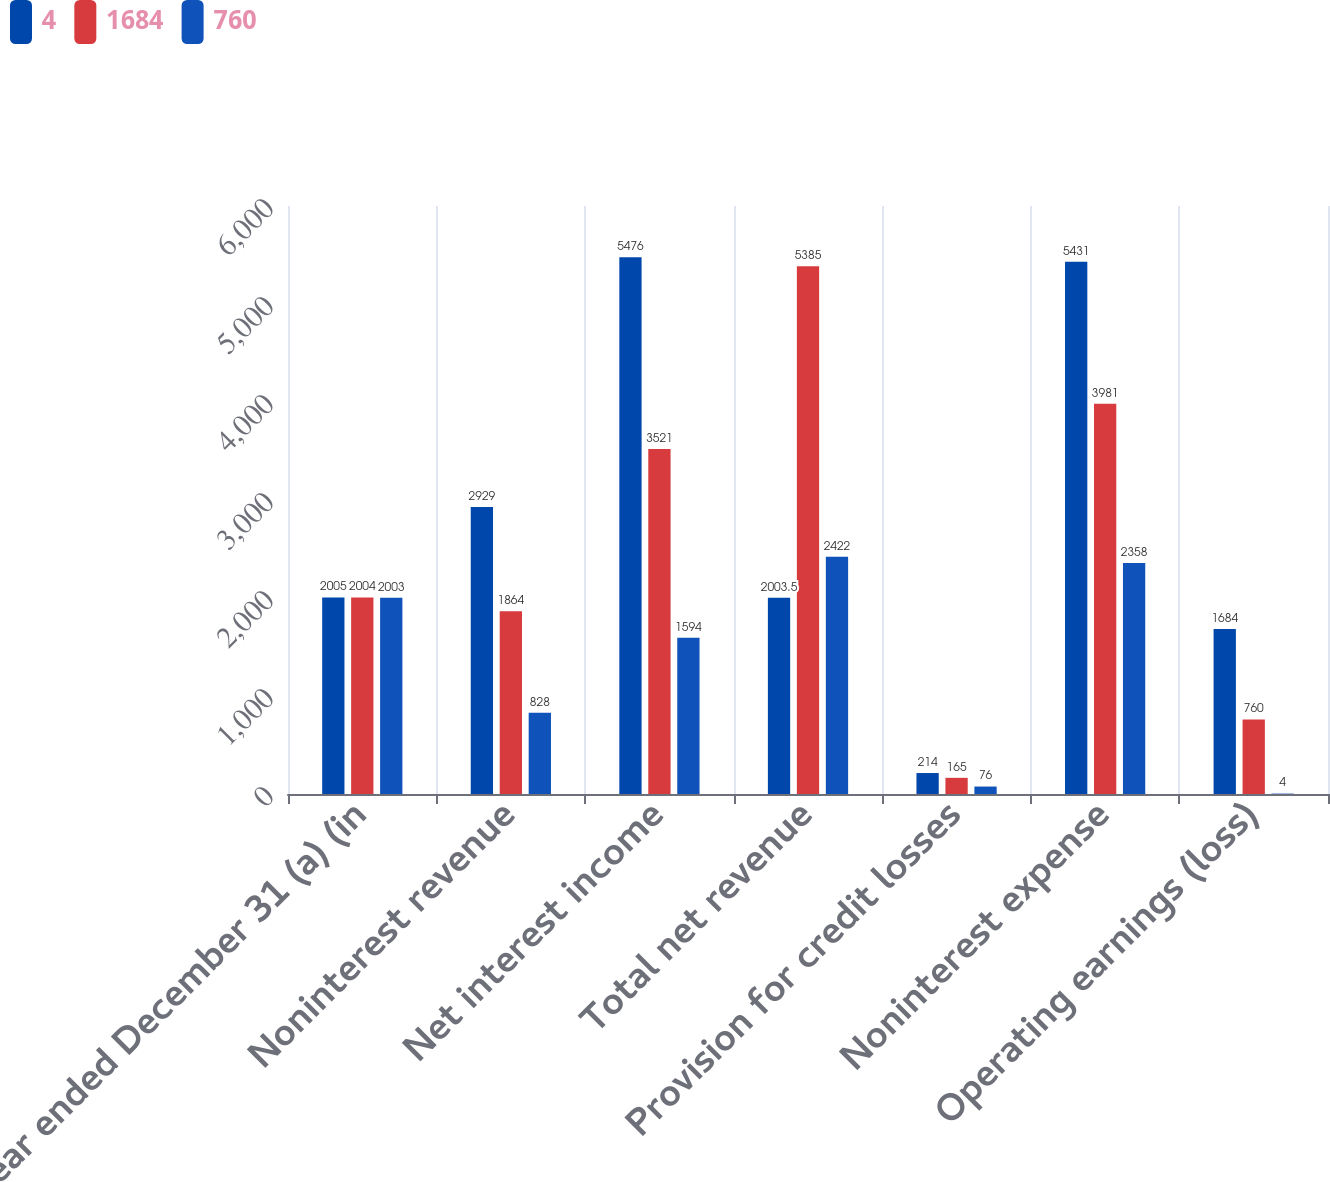Convert chart to OTSL. <chart><loc_0><loc_0><loc_500><loc_500><stacked_bar_chart><ecel><fcel>Year ended December 31 (a) (in<fcel>Noninterest revenue<fcel>Net interest income<fcel>Total net revenue<fcel>Provision for credit losses<fcel>Noninterest expense<fcel>Operating earnings (loss)<nl><fcel>4<fcel>2005<fcel>2929<fcel>5476<fcel>2003.5<fcel>214<fcel>5431<fcel>1684<nl><fcel>1684<fcel>2004<fcel>1864<fcel>3521<fcel>5385<fcel>165<fcel>3981<fcel>760<nl><fcel>760<fcel>2003<fcel>828<fcel>1594<fcel>2422<fcel>76<fcel>2358<fcel>4<nl></chart> 